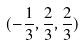Convert formula to latex. <formula><loc_0><loc_0><loc_500><loc_500>( - \frac { 1 } { 3 } , \frac { 2 } { 3 } , \frac { 2 } { 3 } )</formula> 